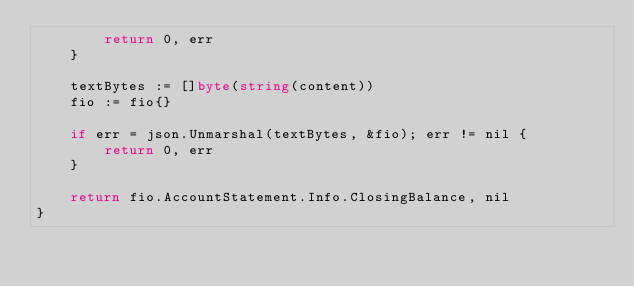Convert code to text. <code><loc_0><loc_0><loc_500><loc_500><_Go_>		return 0, err
	}

	textBytes := []byte(string(content))
	fio := fio{}

	if err = json.Unmarshal(textBytes, &fio); err != nil {
		return 0, err
	}

	return fio.AccountStatement.Info.ClosingBalance, nil
}
</code> 